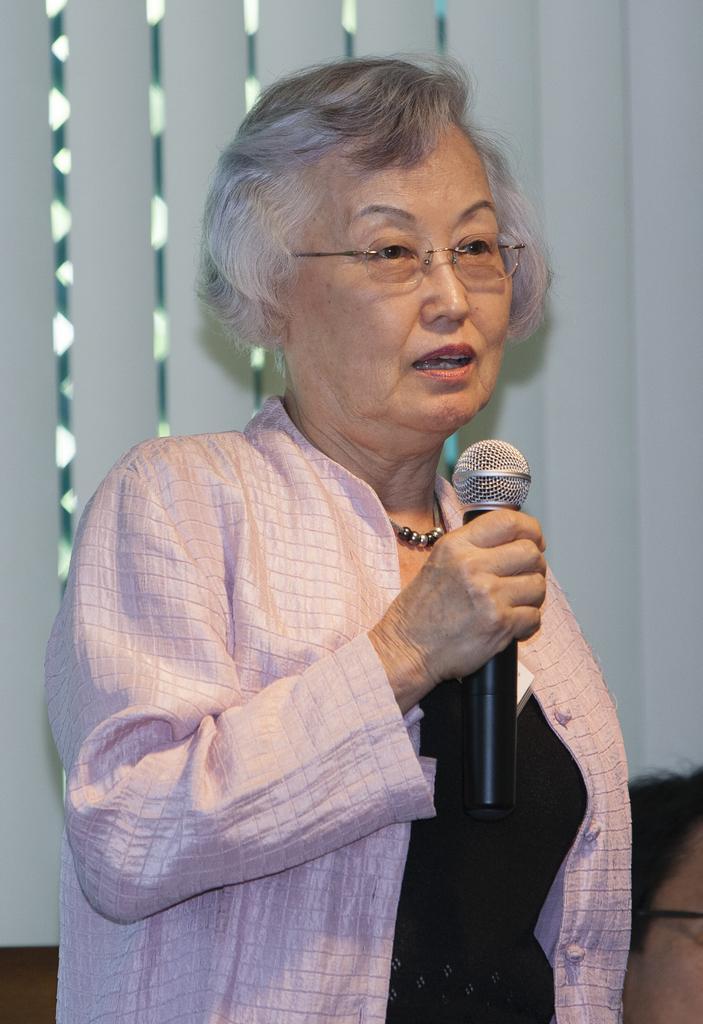Can you describe this image briefly? In this image there is a lady wearing a pink jacket is taking something as her mouth is open. She is holding a mic she is wearing glasses. She is having white hair. In the background there are lights and a white wall. 